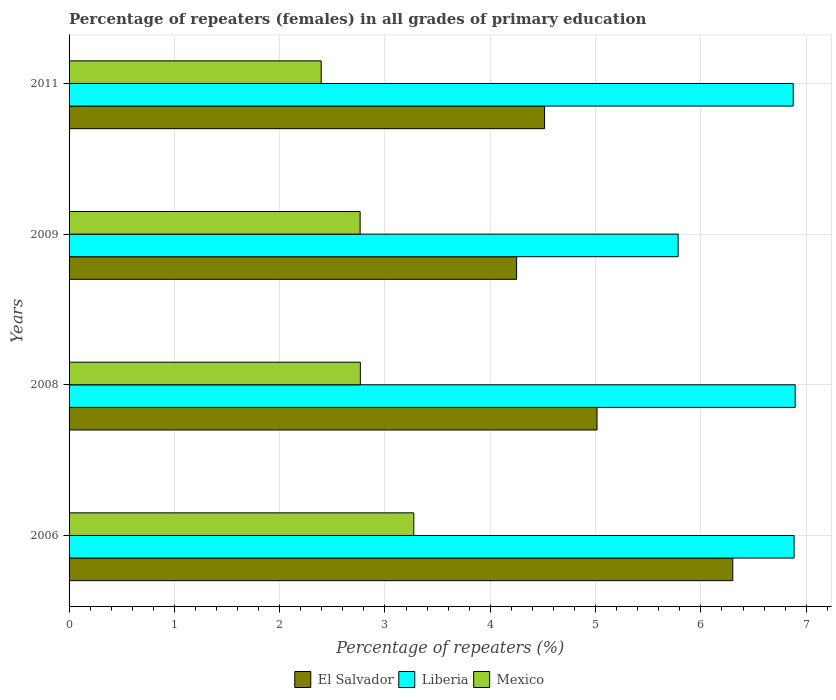How many different coloured bars are there?
Give a very brief answer. 3. Are the number of bars per tick equal to the number of legend labels?
Make the answer very short. Yes. Are the number of bars on each tick of the Y-axis equal?
Provide a short and direct response. Yes. How many bars are there on the 1st tick from the bottom?
Give a very brief answer. 3. What is the percentage of repeaters (females) in Liberia in 2009?
Provide a short and direct response. 5.78. Across all years, what is the maximum percentage of repeaters (females) in El Salvador?
Provide a short and direct response. 6.3. Across all years, what is the minimum percentage of repeaters (females) in Mexico?
Keep it short and to the point. 2.39. In which year was the percentage of repeaters (females) in Mexico minimum?
Your answer should be compact. 2011. What is the total percentage of repeaters (females) in Mexico in the graph?
Offer a very short reply. 11.2. What is the difference between the percentage of repeaters (females) in Mexico in 2006 and that in 2011?
Ensure brevity in your answer.  0.88. What is the difference between the percentage of repeaters (females) in El Salvador in 2009 and the percentage of repeaters (females) in Mexico in 2011?
Your response must be concise. 1.86. What is the average percentage of repeaters (females) in El Salvador per year?
Your answer should be compact. 5.02. In the year 2008, what is the difference between the percentage of repeaters (females) in El Salvador and percentage of repeaters (females) in Mexico?
Your answer should be very brief. 2.25. In how many years, is the percentage of repeaters (females) in Liberia greater than 3.6 %?
Provide a short and direct response. 4. What is the ratio of the percentage of repeaters (females) in Liberia in 2008 to that in 2011?
Make the answer very short. 1. What is the difference between the highest and the second highest percentage of repeaters (females) in Mexico?
Provide a succinct answer. 0.51. What is the difference between the highest and the lowest percentage of repeaters (females) in Liberia?
Your answer should be very brief. 1.11. In how many years, is the percentage of repeaters (females) in Liberia greater than the average percentage of repeaters (females) in Liberia taken over all years?
Give a very brief answer. 3. Is the sum of the percentage of repeaters (females) in Mexico in 2006 and 2011 greater than the maximum percentage of repeaters (females) in Liberia across all years?
Your answer should be compact. No. What does the 2nd bar from the bottom in 2009 represents?
Your answer should be compact. Liberia. Is it the case that in every year, the sum of the percentage of repeaters (females) in Liberia and percentage of repeaters (females) in Mexico is greater than the percentage of repeaters (females) in El Salvador?
Your answer should be very brief. Yes. What is the difference between two consecutive major ticks on the X-axis?
Offer a terse response. 1. Are the values on the major ticks of X-axis written in scientific E-notation?
Provide a short and direct response. No. Where does the legend appear in the graph?
Give a very brief answer. Bottom center. How many legend labels are there?
Make the answer very short. 3. What is the title of the graph?
Your response must be concise. Percentage of repeaters (females) in all grades of primary education. Does "Belize" appear as one of the legend labels in the graph?
Offer a terse response. No. What is the label or title of the X-axis?
Make the answer very short. Percentage of repeaters (%). What is the label or title of the Y-axis?
Offer a very short reply. Years. What is the Percentage of repeaters (%) of El Salvador in 2006?
Offer a very short reply. 6.3. What is the Percentage of repeaters (%) of Liberia in 2006?
Your answer should be very brief. 6.88. What is the Percentage of repeaters (%) in Mexico in 2006?
Keep it short and to the point. 3.27. What is the Percentage of repeaters (%) of El Salvador in 2008?
Provide a succinct answer. 5.01. What is the Percentage of repeaters (%) of Liberia in 2008?
Ensure brevity in your answer.  6.9. What is the Percentage of repeaters (%) in Mexico in 2008?
Provide a short and direct response. 2.77. What is the Percentage of repeaters (%) of El Salvador in 2009?
Your answer should be compact. 4.25. What is the Percentage of repeaters (%) of Liberia in 2009?
Give a very brief answer. 5.78. What is the Percentage of repeaters (%) of Mexico in 2009?
Your answer should be compact. 2.76. What is the Percentage of repeaters (%) of El Salvador in 2011?
Provide a succinct answer. 4.52. What is the Percentage of repeaters (%) in Liberia in 2011?
Give a very brief answer. 6.88. What is the Percentage of repeaters (%) in Mexico in 2011?
Give a very brief answer. 2.39. Across all years, what is the maximum Percentage of repeaters (%) in El Salvador?
Ensure brevity in your answer.  6.3. Across all years, what is the maximum Percentage of repeaters (%) in Liberia?
Provide a succinct answer. 6.9. Across all years, what is the maximum Percentage of repeaters (%) in Mexico?
Provide a short and direct response. 3.27. Across all years, what is the minimum Percentage of repeaters (%) of El Salvador?
Offer a terse response. 4.25. Across all years, what is the minimum Percentage of repeaters (%) of Liberia?
Offer a terse response. 5.78. Across all years, what is the minimum Percentage of repeaters (%) of Mexico?
Ensure brevity in your answer.  2.39. What is the total Percentage of repeaters (%) of El Salvador in the graph?
Provide a short and direct response. 20.08. What is the total Percentage of repeaters (%) of Liberia in the graph?
Offer a very short reply. 26.44. What is the total Percentage of repeaters (%) of Mexico in the graph?
Offer a terse response. 11.2. What is the difference between the Percentage of repeaters (%) in El Salvador in 2006 and that in 2008?
Keep it short and to the point. 1.29. What is the difference between the Percentage of repeaters (%) in Liberia in 2006 and that in 2008?
Provide a succinct answer. -0.01. What is the difference between the Percentage of repeaters (%) in Mexico in 2006 and that in 2008?
Provide a succinct answer. 0.51. What is the difference between the Percentage of repeaters (%) of El Salvador in 2006 and that in 2009?
Offer a very short reply. 2.05. What is the difference between the Percentage of repeaters (%) of Liberia in 2006 and that in 2009?
Your response must be concise. 1.1. What is the difference between the Percentage of repeaters (%) of Mexico in 2006 and that in 2009?
Offer a very short reply. 0.51. What is the difference between the Percentage of repeaters (%) of El Salvador in 2006 and that in 2011?
Give a very brief answer. 1.79. What is the difference between the Percentage of repeaters (%) in Liberia in 2006 and that in 2011?
Your response must be concise. 0.01. What is the difference between the Percentage of repeaters (%) of Mexico in 2006 and that in 2011?
Give a very brief answer. 0.88. What is the difference between the Percentage of repeaters (%) of El Salvador in 2008 and that in 2009?
Offer a terse response. 0.76. What is the difference between the Percentage of repeaters (%) of Liberia in 2008 and that in 2009?
Ensure brevity in your answer.  1.11. What is the difference between the Percentage of repeaters (%) of Mexico in 2008 and that in 2009?
Provide a succinct answer. 0. What is the difference between the Percentage of repeaters (%) in El Salvador in 2008 and that in 2011?
Keep it short and to the point. 0.5. What is the difference between the Percentage of repeaters (%) in Liberia in 2008 and that in 2011?
Keep it short and to the point. 0.02. What is the difference between the Percentage of repeaters (%) in Mexico in 2008 and that in 2011?
Offer a very short reply. 0.37. What is the difference between the Percentage of repeaters (%) in El Salvador in 2009 and that in 2011?
Your response must be concise. -0.27. What is the difference between the Percentage of repeaters (%) of Liberia in 2009 and that in 2011?
Give a very brief answer. -1.09. What is the difference between the Percentage of repeaters (%) in Mexico in 2009 and that in 2011?
Keep it short and to the point. 0.37. What is the difference between the Percentage of repeaters (%) in El Salvador in 2006 and the Percentage of repeaters (%) in Liberia in 2008?
Give a very brief answer. -0.59. What is the difference between the Percentage of repeaters (%) in El Salvador in 2006 and the Percentage of repeaters (%) in Mexico in 2008?
Provide a short and direct response. 3.54. What is the difference between the Percentage of repeaters (%) in Liberia in 2006 and the Percentage of repeaters (%) in Mexico in 2008?
Offer a very short reply. 4.12. What is the difference between the Percentage of repeaters (%) in El Salvador in 2006 and the Percentage of repeaters (%) in Liberia in 2009?
Provide a succinct answer. 0.52. What is the difference between the Percentage of repeaters (%) in El Salvador in 2006 and the Percentage of repeaters (%) in Mexico in 2009?
Provide a succinct answer. 3.54. What is the difference between the Percentage of repeaters (%) in Liberia in 2006 and the Percentage of repeaters (%) in Mexico in 2009?
Offer a very short reply. 4.12. What is the difference between the Percentage of repeaters (%) of El Salvador in 2006 and the Percentage of repeaters (%) of Liberia in 2011?
Keep it short and to the point. -0.57. What is the difference between the Percentage of repeaters (%) in El Salvador in 2006 and the Percentage of repeaters (%) in Mexico in 2011?
Keep it short and to the point. 3.91. What is the difference between the Percentage of repeaters (%) in Liberia in 2006 and the Percentage of repeaters (%) in Mexico in 2011?
Offer a terse response. 4.49. What is the difference between the Percentage of repeaters (%) of El Salvador in 2008 and the Percentage of repeaters (%) of Liberia in 2009?
Offer a very short reply. -0.77. What is the difference between the Percentage of repeaters (%) of El Salvador in 2008 and the Percentage of repeaters (%) of Mexico in 2009?
Your response must be concise. 2.25. What is the difference between the Percentage of repeaters (%) in Liberia in 2008 and the Percentage of repeaters (%) in Mexico in 2009?
Your answer should be compact. 4.13. What is the difference between the Percentage of repeaters (%) of El Salvador in 2008 and the Percentage of repeaters (%) of Liberia in 2011?
Keep it short and to the point. -1.86. What is the difference between the Percentage of repeaters (%) of El Salvador in 2008 and the Percentage of repeaters (%) of Mexico in 2011?
Ensure brevity in your answer.  2.62. What is the difference between the Percentage of repeaters (%) of Liberia in 2008 and the Percentage of repeaters (%) of Mexico in 2011?
Provide a succinct answer. 4.5. What is the difference between the Percentage of repeaters (%) in El Salvador in 2009 and the Percentage of repeaters (%) in Liberia in 2011?
Your response must be concise. -2.63. What is the difference between the Percentage of repeaters (%) of El Salvador in 2009 and the Percentage of repeaters (%) of Mexico in 2011?
Keep it short and to the point. 1.86. What is the difference between the Percentage of repeaters (%) in Liberia in 2009 and the Percentage of repeaters (%) in Mexico in 2011?
Your answer should be very brief. 3.39. What is the average Percentage of repeaters (%) of El Salvador per year?
Your answer should be compact. 5.02. What is the average Percentage of repeaters (%) in Liberia per year?
Provide a short and direct response. 6.61. What is the average Percentage of repeaters (%) of Mexico per year?
Offer a very short reply. 2.8. In the year 2006, what is the difference between the Percentage of repeaters (%) in El Salvador and Percentage of repeaters (%) in Liberia?
Your answer should be very brief. -0.58. In the year 2006, what is the difference between the Percentage of repeaters (%) in El Salvador and Percentage of repeaters (%) in Mexico?
Make the answer very short. 3.03. In the year 2006, what is the difference between the Percentage of repeaters (%) in Liberia and Percentage of repeaters (%) in Mexico?
Your answer should be very brief. 3.61. In the year 2008, what is the difference between the Percentage of repeaters (%) of El Salvador and Percentage of repeaters (%) of Liberia?
Your response must be concise. -1.88. In the year 2008, what is the difference between the Percentage of repeaters (%) of El Salvador and Percentage of repeaters (%) of Mexico?
Offer a very short reply. 2.25. In the year 2008, what is the difference between the Percentage of repeaters (%) of Liberia and Percentage of repeaters (%) of Mexico?
Provide a short and direct response. 4.13. In the year 2009, what is the difference between the Percentage of repeaters (%) in El Salvador and Percentage of repeaters (%) in Liberia?
Keep it short and to the point. -1.53. In the year 2009, what is the difference between the Percentage of repeaters (%) of El Salvador and Percentage of repeaters (%) of Mexico?
Offer a very short reply. 1.49. In the year 2009, what is the difference between the Percentage of repeaters (%) in Liberia and Percentage of repeaters (%) in Mexico?
Ensure brevity in your answer.  3.02. In the year 2011, what is the difference between the Percentage of repeaters (%) of El Salvador and Percentage of repeaters (%) of Liberia?
Offer a very short reply. -2.36. In the year 2011, what is the difference between the Percentage of repeaters (%) in El Salvador and Percentage of repeaters (%) in Mexico?
Offer a terse response. 2.12. In the year 2011, what is the difference between the Percentage of repeaters (%) of Liberia and Percentage of repeaters (%) of Mexico?
Give a very brief answer. 4.48. What is the ratio of the Percentage of repeaters (%) in El Salvador in 2006 to that in 2008?
Your response must be concise. 1.26. What is the ratio of the Percentage of repeaters (%) in Mexico in 2006 to that in 2008?
Offer a very short reply. 1.18. What is the ratio of the Percentage of repeaters (%) in El Salvador in 2006 to that in 2009?
Provide a succinct answer. 1.48. What is the ratio of the Percentage of repeaters (%) in Liberia in 2006 to that in 2009?
Provide a succinct answer. 1.19. What is the ratio of the Percentage of repeaters (%) of Mexico in 2006 to that in 2009?
Make the answer very short. 1.18. What is the ratio of the Percentage of repeaters (%) in El Salvador in 2006 to that in 2011?
Provide a short and direct response. 1.4. What is the ratio of the Percentage of repeaters (%) in Liberia in 2006 to that in 2011?
Your answer should be very brief. 1. What is the ratio of the Percentage of repeaters (%) in Mexico in 2006 to that in 2011?
Offer a terse response. 1.37. What is the ratio of the Percentage of repeaters (%) of El Salvador in 2008 to that in 2009?
Ensure brevity in your answer.  1.18. What is the ratio of the Percentage of repeaters (%) in Liberia in 2008 to that in 2009?
Offer a terse response. 1.19. What is the ratio of the Percentage of repeaters (%) of El Salvador in 2008 to that in 2011?
Keep it short and to the point. 1.11. What is the ratio of the Percentage of repeaters (%) in Mexico in 2008 to that in 2011?
Your answer should be very brief. 1.16. What is the ratio of the Percentage of repeaters (%) in Liberia in 2009 to that in 2011?
Your answer should be very brief. 0.84. What is the ratio of the Percentage of repeaters (%) of Mexico in 2009 to that in 2011?
Your answer should be very brief. 1.15. What is the difference between the highest and the second highest Percentage of repeaters (%) in El Salvador?
Offer a very short reply. 1.29. What is the difference between the highest and the second highest Percentage of repeaters (%) in Liberia?
Your answer should be compact. 0.01. What is the difference between the highest and the second highest Percentage of repeaters (%) in Mexico?
Offer a very short reply. 0.51. What is the difference between the highest and the lowest Percentage of repeaters (%) of El Salvador?
Your response must be concise. 2.05. What is the difference between the highest and the lowest Percentage of repeaters (%) in Liberia?
Provide a short and direct response. 1.11. What is the difference between the highest and the lowest Percentage of repeaters (%) in Mexico?
Ensure brevity in your answer.  0.88. 